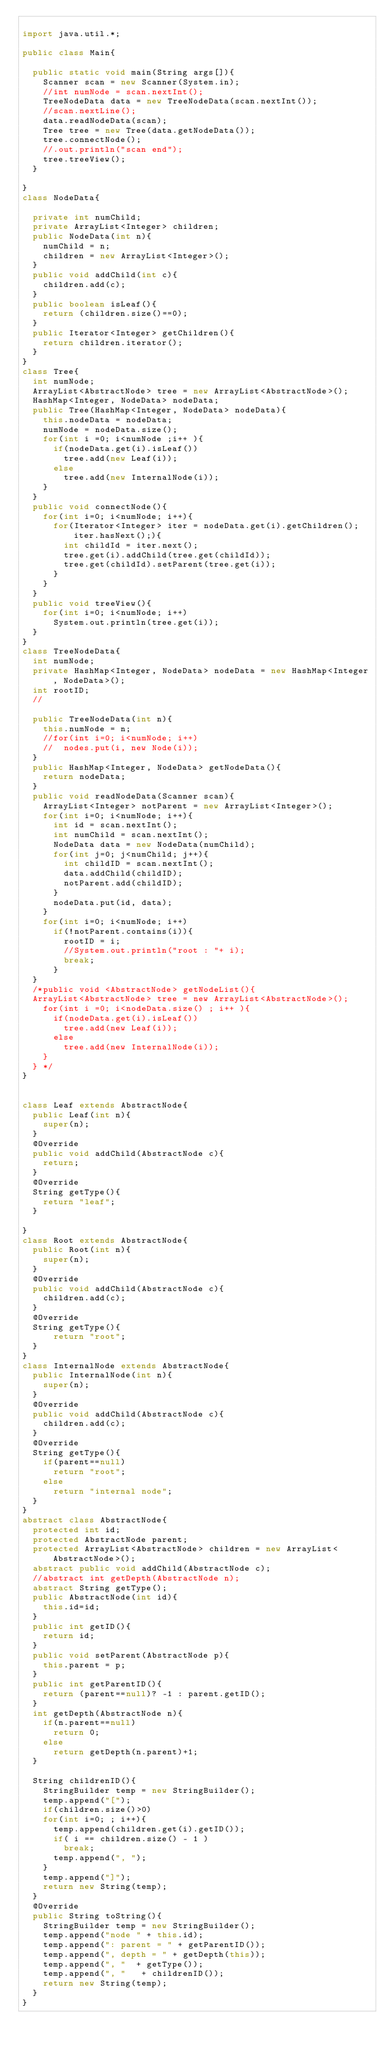Convert code to text. <code><loc_0><loc_0><loc_500><loc_500><_Java_>
import java.util.*;

public class Main{ 

	public static void main(String args[]){
		Scanner scan = new Scanner(System.in);
		//int numNode = scan.nextInt();
		TreeNodeData data = new TreeNodeData(scan.nextInt());
		//scan.nextLine();
		data.readNodeData(scan);
		Tree tree = new Tree(data.getNodeData());
		tree.connectNode();
		//.out.println("scan end");
		tree.treeView();
	}

}
class NodeData{

	private int numChild;
	private ArrayList<Integer> children;
	public NodeData(int n){
		numChild = n;
		children = new ArrayList<Integer>();
	}
	public void addChild(int c){
		children.add(c);
	}
	public boolean isLeaf(){
		return (children.size()==0);
	}
	public Iterator<Integer> getChildren(){
		return children.iterator();
	}
}
class Tree{
	int numNode;
	ArrayList<AbstractNode> tree = new ArrayList<AbstractNode>();
	HashMap<Integer, NodeData> nodeData;
	public Tree(HashMap<Integer, NodeData> nodeData){
		this.nodeData = nodeData;
		numNode = nodeData.size();
		for(int i =0; i<numNode ;i++ ){
			if(nodeData.get(i).isLeaf())
				tree.add(new Leaf(i));
			else
				tree.add(new InternalNode(i));
		}
	}
	public void connectNode(){
		for(int i=0; i<numNode; i++){
			for(Iterator<Integer> iter = nodeData.get(i).getChildren(); iter.hasNext();){
				int childId = iter.next();
				tree.get(i).addChild(tree.get(childId));
				tree.get(childId).setParent(tree.get(i));
			}
		}
	}
	public void treeView(){
		for(int i=0; i<numNode; i++)
			System.out.println(tree.get(i));
	}
}
class TreeNodeData{
	int numNode;
	private HashMap<Integer, NodeData> nodeData = new HashMap<Integer, NodeData>();
	int rootID;
	//

	public TreeNodeData(int n){
		this.numNode = n;
		//for(int i=0; i<numNode; i++)
		//	nodes.put(i, new Node(i));	
	}
	public HashMap<Integer, NodeData> getNodeData(){
		return nodeData;
	}
	public void readNodeData(Scanner scan){
		ArrayList<Integer> notParent = new ArrayList<Integer>();
		for(int i=0; i<numNode; i++){
			int id = scan.nextInt();
			int numChild = scan.nextInt();
			NodeData data = new NodeData(numChild);
			for(int j=0; j<numChild; j++){
				int childID = scan.nextInt();
				data.addChild(childID);
				notParent.add(childID);
			}
			nodeData.put(id, data);
		}
		for(int i=0; i<numNode; i++)
			if(!notParent.contains(i)){
				rootID = i;
				//System.out.println("root : "+ i);
				break;
			}
	}
	/*public void <AbstractNode> getNodeList(){
	ArrayList<AbstractNode> tree = new ArrayList<AbstractNode>();
		for(int i =0; i<nodeData.size() ; i++ ){
			if(nodeData.get(i).isLeaf())
				tree.add(new Leaf(i));
			else
				tree.add(new InternalNode(i));
		}		
	} */
}


class Leaf extends AbstractNode{
	public Leaf(int n){
		super(n);
	}
	@Override 
	public void addChild(AbstractNode c){
		return;
	}
	@Override 
	String getType(){
		return "leaf";
	}

}
class Root extends AbstractNode{
	public Root(int n){
		super(n);
	}
	@Override 
	public void addChild(AbstractNode c){
		children.add(c);
	}
	@Override 
	String getType(){
			return "root";
	}
}
class InternalNode extends AbstractNode{
	public InternalNode(int n){
		super(n);
	}
	@Override 
	public void addChild(AbstractNode c){
		children.add(c);
	}
	@Override 
	String getType(){
		if(parent==null)
			return "root";
		else
			return "internal node";
	}
}
abstract class AbstractNode{
	protected int id;
	protected AbstractNode parent;
	protected ArrayList<AbstractNode> children = new ArrayList<AbstractNode>();
	abstract public void addChild(AbstractNode c);
	//abstract int getDepth(AbstractNode n);
	abstract String getType();
	public AbstractNode(int id){
		this.id=id;
	}
	public int getID(){
		return id;
	}
	public void setParent(AbstractNode p){
		this.parent = p;
	}
	public int getParentID(){
		return (parent==null)? -1 : parent.getID();
	}
	int getDepth(AbstractNode n){
		if(n.parent==null)
			return 0;
		else
			return getDepth(n.parent)+1;
	}

	String childrenID(){
		StringBuilder temp = new StringBuilder();
		temp.append("[");
		if(children.size()>0)
		for(int i=0; ; i++){
			temp.append(children.get(i).getID());
			if( i == children.size() - 1 )
				break;
			temp.append(", ");
		}
		temp.append("]");
		return new String(temp);
	}
	@Override
	public String toString(){
		StringBuilder temp = new StringBuilder();
		temp.append("node " + this.id);
		temp.append(": parent = " + getParentID());
		temp.append(", depth = " + getDepth(this));
		temp.append(", "  + getType());
		temp.append(", "   + childrenID());
		return new String(temp);
	}
}</code> 